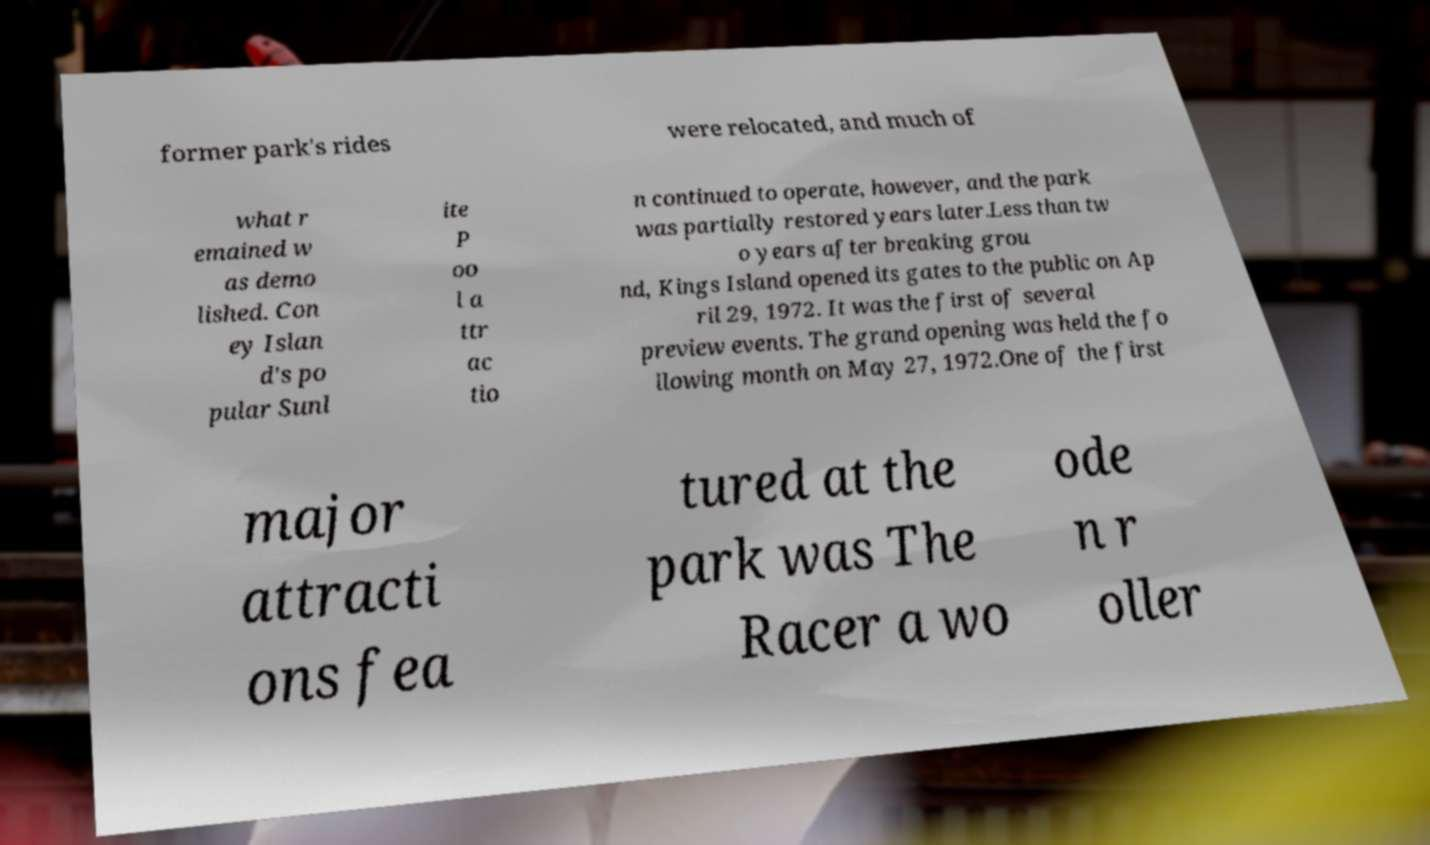Please read and relay the text visible in this image. What does it say? former park's rides were relocated, and much of what r emained w as demo lished. Con ey Islan d's po pular Sunl ite P oo l a ttr ac tio n continued to operate, however, and the park was partially restored years later.Less than tw o years after breaking grou nd, Kings Island opened its gates to the public on Ap ril 29, 1972. It was the first of several preview events. The grand opening was held the fo llowing month on May 27, 1972.One of the first major attracti ons fea tured at the park was The Racer a wo ode n r oller 